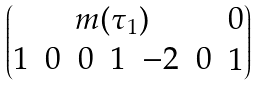<formula> <loc_0><loc_0><loc_500><loc_500>\begin{pmatrix} m ( \tau _ { 1 } ) & { 0 } \\ \begin{matrix} 1 & 0 & 0 & 1 & - 2 & 0 \end{matrix} & 1 \end{pmatrix}</formula> 